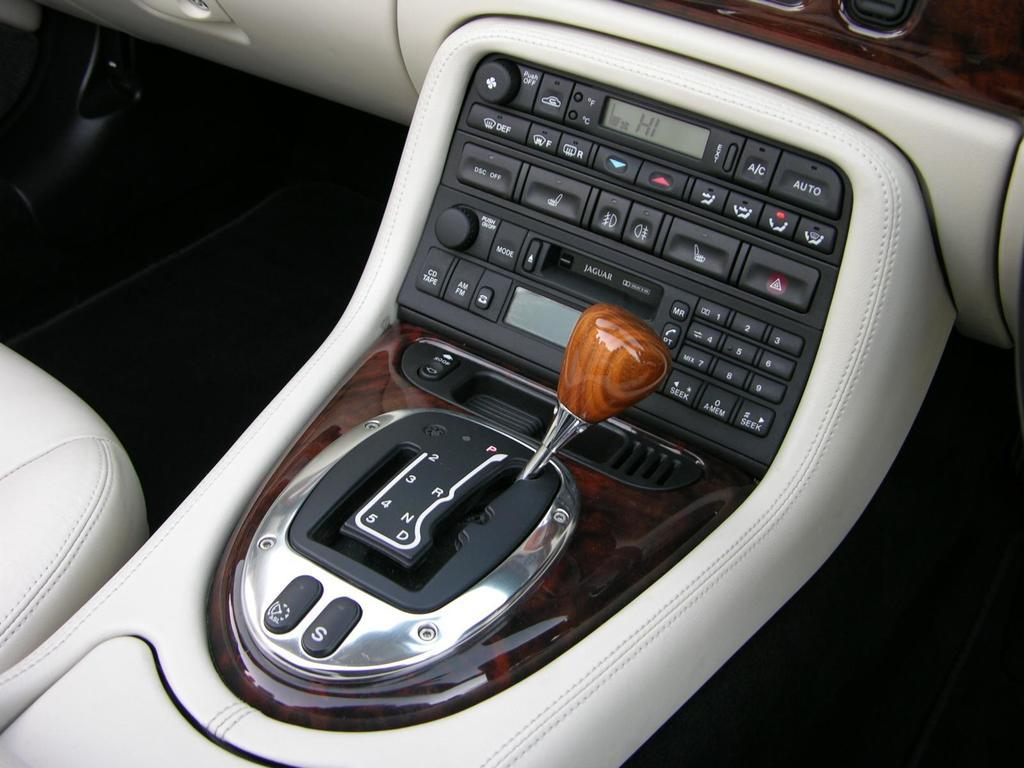What is the main subject of the image? The main subject of the image is a car gear. What feature can be seen on the car gear? There are buttons on the car gear. What type of silver material is used to make the arm of the car gear? There is no mention of silver or an arm in the image, as it only features a car gear with buttons. 